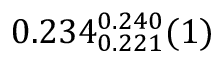<formula> <loc_0><loc_0><loc_500><loc_500>0 . 2 3 4 _ { 0 . 2 2 1 } ^ { 0 . 2 4 0 } ( 1 )</formula> 